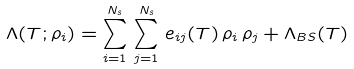<formula> <loc_0><loc_0><loc_500><loc_500>\Lambda ( T ; \rho _ { i } ) = \sum _ { i = 1 } ^ { N _ { s } } \, \sum _ { j = 1 } ^ { N _ { s } } \, e _ { i j } ( T ) \, \rho _ { i } \, \rho _ { j } + \Lambda _ { B S } ( T )</formula> 